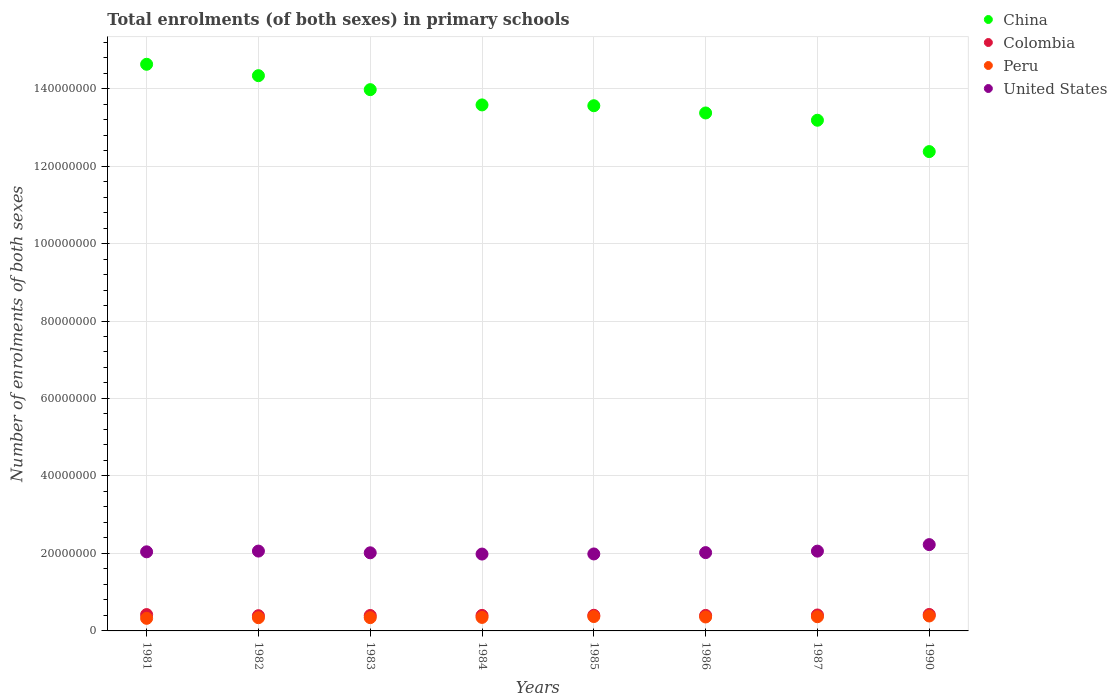Is the number of dotlines equal to the number of legend labels?
Your answer should be very brief. Yes. What is the number of enrolments in primary schools in Peru in 1981?
Your answer should be very brief. 3.25e+06. Across all years, what is the maximum number of enrolments in primary schools in Colombia?
Keep it short and to the point. 4.25e+06. Across all years, what is the minimum number of enrolments in primary schools in Colombia?
Give a very brief answer. 3.93e+06. In which year was the number of enrolments in primary schools in Colombia maximum?
Your response must be concise. 1990. What is the total number of enrolments in primary schools in Colombia in the graph?
Your answer should be compact. 3.25e+07. What is the difference between the number of enrolments in primary schools in United States in 1982 and that in 1983?
Provide a short and direct response. 4.43e+05. What is the difference between the number of enrolments in primary schools in China in 1990 and the number of enrolments in primary schools in United States in 1987?
Ensure brevity in your answer.  1.03e+08. What is the average number of enrolments in primary schools in United States per year?
Your response must be concise. 2.05e+07. In the year 1984, what is the difference between the number of enrolments in primary schools in Peru and number of enrolments in primary schools in Colombia?
Your answer should be very brief. -5.24e+05. In how many years, is the number of enrolments in primary schools in United States greater than 88000000?
Provide a succinct answer. 0. What is the ratio of the number of enrolments in primary schools in United States in 1983 to that in 1986?
Give a very brief answer. 1. What is the difference between the highest and the second highest number of enrolments in primary schools in United States?
Keep it short and to the point. 1.67e+06. What is the difference between the highest and the lowest number of enrolments in primary schools in China?
Your answer should be very brief. 2.25e+07. Is the sum of the number of enrolments in primary schools in China in 1983 and 1987 greater than the maximum number of enrolments in primary schools in Colombia across all years?
Give a very brief answer. Yes. Is it the case that in every year, the sum of the number of enrolments in primary schools in Colombia and number of enrolments in primary schools in Peru  is greater than the sum of number of enrolments in primary schools in China and number of enrolments in primary schools in United States?
Give a very brief answer. No. Is it the case that in every year, the sum of the number of enrolments in primary schools in China and number of enrolments in primary schools in Colombia  is greater than the number of enrolments in primary schools in United States?
Make the answer very short. Yes. Does the number of enrolments in primary schools in China monotonically increase over the years?
Keep it short and to the point. No. Is the number of enrolments in primary schools in China strictly less than the number of enrolments in primary schools in Colombia over the years?
Your answer should be compact. No. How many dotlines are there?
Your answer should be compact. 4. What is the difference between two consecutive major ticks on the Y-axis?
Offer a very short reply. 2.00e+07. Are the values on the major ticks of Y-axis written in scientific E-notation?
Your answer should be compact. No. Does the graph contain any zero values?
Keep it short and to the point. No. What is the title of the graph?
Keep it short and to the point. Total enrolments (of both sexes) in primary schools. Does "Poland" appear as one of the legend labels in the graph?
Ensure brevity in your answer.  No. What is the label or title of the Y-axis?
Offer a very short reply. Number of enrolments of both sexes. What is the Number of enrolments of both sexes of China in 1981?
Make the answer very short. 1.46e+08. What is the Number of enrolments of both sexes in Colombia in 1981?
Provide a short and direct response. 4.22e+06. What is the Number of enrolments of both sexes of Peru in 1981?
Keep it short and to the point. 3.25e+06. What is the Number of enrolments of both sexes of United States in 1981?
Your answer should be very brief. 2.04e+07. What is the Number of enrolments of both sexes of China in 1982?
Your response must be concise. 1.43e+08. What is the Number of enrolments of both sexes of Colombia in 1982?
Give a very brief answer. 3.93e+06. What is the Number of enrolments of both sexes in Peru in 1982?
Ensure brevity in your answer.  3.41e+06. What is the Number of enrolments of both sexes of United States in 1982?
Provide a short and direct response. 2.06e+07. What is the Number of enrolments of both sexes of China in 1983?
Offer a terse response. 1.40e+08. What is the Number of enrolments of both sexes of Colombia in 1983?
Provide a short and direct response. 3.98e+06. What is the Number of enrolments of both sexes in Peru in 1983?
Offer a very short reply. 3.43e+06. What is the Number of enrolments of both sexes in United States in 1983?
Your answer should be compact. 2.02e+07. What is the Number of enrolments of both sexes in China in 1984?
Offer a very short reply. 1.36e+08. What is the Number of enrolments of both sexes in Colombia in 1984?
Ensure brevity in your answer.  4.01e+06. What is the Number of enrolments of both sexes in Peru in 1984?
Offer a terse response. 3.48e+06. What is the Number of enrolments of both sexes of United States in 1984?
Provide a short and direct response. 1.98e+07. What is the Number of enrolments of both sexes of China in 1985?
Your answer should be very brief. 1.36e+08. What is the Number of enrolments of both sexes of Colombia in 1985?
Your answer should be compact. 4.04e+06. What is the Number of enrolments of both sexes in Peru in 1985?
Keep it short and to the point. 3.71e+06. What is the Number of enrolments of both sexes in United States in 1985?
Provide a succinct answer. 1.99e+07. What is the Number of enrolments of both sexes of China in 1986?
Your answer should be compact. 1.34e+08. What is the Number of enrolments of both sexes of Colombia in 1986?
Give a very brief answer. 4.00e+06. What is the Number of enrolments of both sexes in Peru in 1986?
Your answer should be compact. 3.60e+06. What is the Number of enrolments of both sexes in United States in 1986?
Your response must be concise. 2.02e+07. What is the Number of enrolments of both sexes in China in 1987?
Make the answer very short. 1.32e+08. What is the Number of enrolments of both sexes of Colombia in 1987?
Make the answer very short. 4.11e+06. What is the Number of enrolments of both sexes of Peru in 1987?
Your response must be concise. 3.66e+06. What is the Number of enrolments of both sexes of United States in 1987?
Your answer should be very brief. 2.06e+07. What is the Number of enrolments of both sexes of China in 1990?
Provide a short and direct response. 1.24e+08. What is the Number of enrolments of both sexes in Colombia in 1990?
Your answer should be very brief. 4.25e+06. What is the Number of enrolments of both sexes of Peru in 1990?
Make the answer very short. 3.86e+06. What is the Number of enrolments of both sexes of United States in 1990?
Make the answer very short. 2.23e+07. Across all years, what is the maximum Number of enrolments of both sexes in China?
Keep it short and to the point. 1.46e+08. Across all years, what is the maximum Number of enrolments of both sexes of Colombia?
Your response must be concise. 4.25e+06. Across all years, what is the maximum Number of enrolments of both sexes in Peru?
Offer a very short reply. 3.86e+06. Across all years, what is the maximum Number of enrolments of both sexes of United States?
Offer a very short reply. 2.23e+07. Across all years, what is the minimum Number of enrolments of both sexes in China?
Your answer should be very brief. 1.24e+08. Across all years, what is the minimum Number of enrolments of both sexes in Colombia?
Your answer should be compact. 3.93e+06. Across all years, what is the minimum Number of enrolments of both sexes in Peru?
Offer a very short reply. 3.25e+06. Across all years, what is the minimum Number of enrolments of both sexes of United States?
Offer a very short reply. 1.98e+07. What is the total Number of enrolments of both sexes in China in the graph?
Give a very brief answer. 1.09e+09. What is the total Number of enrolments of both sexes in Colombia in the graph?
Your response must be concise. 3.25e+07. What is the total Number of enrolments of both sexes of Peru in the graph?
Offer a very short reply. 2.84e+07. What is the total Number of enrolments of both sexes in United States in the graph?
Provide a succinct answer. 1.64e+08. What is the difference between the Number of enrolments of both sexes in China in 1981 and that in 1982?
Provide a succinct answer. 2.94e+06. What is the difference between the Number of enrolments of both sexes in Colombia in 1981 and that in 1982?
Your answer should be very brief. 2.87e+05. What is the difference between the Number of enrolments of both sexes in Peru in 1981 and that in 1982?
Provide a succinct answer. -1.61e+05. What is the difference between the Number of enrolments of both sexes of United States in 1981 and that in 1982?
Give a very brief answer. -1.89e+05. What is the difference between the Number of enrolments of both sexes in China in 1981 and that in 1983?
Keep it short and to the point. 6.55e+06. What is the difference between the Number of enrolments of both sexes in Colombia in 1981 and that in 1983?
Provide a succinct answer. 2.35e+05. What is the difference between the Number of enrolments of both sexes of Peru in 1981 and that in 1983?
Your response must be concise. -1.76e+05. What is the difference between the Number of enrolments of both sexes of United States in 1981 and that in 1983?
Your response must be concise. 2.54e+05. What is the difference between the Number of enrolments of both sexes in China in 1981 and that in 1984?
Give a very brief answer. 1.05e+07. What is the difference between the Number of enrolments of both sexes in Colombia in 1981 and that in 1984?
Your response must be concise. 2.08e+05. What is the difference between the Number of enrolments of both sexes of Peru in 1981 and that in 1984?
Your response must be concise. -2.33e+05. What is the difference between the Number of enrolments of both sexes of United States in 1981 and that in 1984?
Your response must be concise. 5.80e+05. What is the difference between the Number of enrolments of both sexes in China in 1981 and that in 1985?
Give a very brief answer. 1.07e+07. What is the difference between the Number of enrolments of both sexes of Colombia in 1981 and that in 1985?
Ensure brevity in your answer.  1.78e+05. What is the difference between the Number of enrolments of both sexes of Peru in 1981 and that in 1985?
Your response must be concise. -4.60e+05. What is the difference between the Number of enrolments of both sexes of United States in 1981 and that in 1985?
Give a very brief answer. 5.51e+05. What is the difference between the Number of enrolments of both sexes in China in 1981 and that in 1986?
Offer a terse response. 1.26e+07. What is the difference between the Number of enrolments of both sexes of Colombia in 1981 and that in 1986?
Your answer should be very brief. 2.15e+05. What is the difference between the Number of enrolments of both sexes in Peru in 1981 and that in 1986?
Your answer should be very brief. -3.49e+05. What is the difference between the Number of enrolments of both sexes in United States in 1981 and that in 1986?
Provide a short and direct response. 2.06e+05. What is the difference between the Number of enrolments of both sexes of China in 1981 and that in 1987?
Keep it short and to the point. 1.44e+07. What is the difference between the Number of enrolments of both sexes in Colombia in 1981 and that in 1987?
Your answer should be compact. 1.03e+05. What is the difference between the Number of enrolments of both sexes in Peru in 1981 and that in 1987?
Offer a very short reply. -4.11e+05. What is the difference between the Number of enrolments of both sexes of United States in 1981 and that in 1987?
Your answer should be compact. -1.75e+05. What is the difference between the Number of enrolments of both sexes in China in 1981 and that in 1990?
Your answer should be compact. 2.25e+07. What is the difference between the Number of enrolments of both sexes in Colombia in 1981 and that in 1990?
Give a very brief answer. -2.89e+04. What is the difference between the Number of enrolments of both sexes of Peru in 1981 and that in 1990?
Give a very brief answer. -6.03e+05. What is the difference between the Number of enrolments of both sexes in United States in 1981 and that in 1990?
Ensure brevity in your answer.  -1.86e+06. What is the difference between the Number of enrolments of both sexes in China in 1982 and that in 1983?
Keep it short and to the point. 3.61e+06. What is the difference between the Number of enrolments of both sexes of Colombia in 1982 and that in 1983?
Provide a short and direct response. -5.28e+04. What is the difference between the Number of enrolments of both sexes of Peru in 1982 and that in 1983?
Your response must be concise. -1.51e+04. What is the difference between the Number of enrolments of both sexes in United States in 1982 and that in 1983?
Make the answer very short. 4.43e+05. What is the difference between the Number of enrolments of both sexes of China in 1982 and that in 1984?
Offer a terse response. 7.55e+06. What is the difference between the Number of enrolments of both sexes of Colombia in 1982 and that in 1984?
Keep it short and to the point. -7.91e+04. What is the difference between the Number of enrolments of both sexes of Peru in 1982 and that in 1984?
Ensure brevity in your answer.  -7.22e+04. What is the difference between the Number of enrolments of both sexes of United States in 1982 and that in 1984?
Offer a terse response. 7.69e+05. What is the difference between the Number of enrolments of both sexes in China in 1982 and that in 1985?
Your response must be concise. 7.76e+06. What is the difference between the Number of enrolments of both sexes of Colombia in 1982 and that in 1985?
Offer a very short reply. -1.09e+05. What is the difference between the Number of enrolments of both sexes of Peru in 1982 and that in 1985?
Your response must be concise. -2.99e+05. What is the difference between the Number of enrolments of both sexes in United States in 1982 and that in 1985?
Ensure brevity in your answer.  7.40e+05. What is the difference between the Number of enrolments of both sexes of China in 1982 and that in 1986?
Your answer should be compact. 9.63e+06. What is the difference between the Number of enrolments of both sexes in Colombia in 1982 and that in 1986?
Offer a terse response. -7.22e+04. What is the difference between the Number of enrolments of both sexes of Peru in 1982 and that in 1986?
Provide a short and direct response. -1.88e+05. What is the difference between the Number of enrolments of both sexes in United States in 1982 and that in 1986?
Provide a short and direct response. 3.95e+05. What is the difference between the Number of enrolments of both sexes of China in 1982 and that in 1987?
Your answer should be very brief. 1.15e+07. What is the difference between the Number of enrolments of both sexes in Colombia in 1982 and that in 1987?
Your answer should be very brief. -1.85e+05. What is the difference between the Number of enrolments of both sexes of Peru in 1982 and that in 1987?
Offer a very short reply. -2.50e+05. What is the difference between the Number of enrolments of both sexes in United States in 1982 and that in 1987?
Offer a terse response. 1.40e+04. What is the difference between the Number of enrolments of both sexes of China in 1982 and that in 1990?
Ensure brevity in your answer.  1.96e+07. What is the difference between the Number of enrolments of both sexes in Colombia in 1982 and that in 1990?
Offer a very short reply. -3.16e+05. What is the difference between the Number of enrolments of both sexes in Peru in 1982 and that in 1990?
Offer a terse response. -4.43e+05. What is the difference between the Number of enrolments of both sexes in United States in 1982 and that in 1990?
Provide a short and direct response. -1.67e+06. What is the difference between the Number of enrolments of both sexes in China in 1983 and that in 1984?
Give a very brief answer. 3.94e+06. What is the difference between the Number of enrolments of both sexes of Colombia in 1983 and that in 1984?
Your response must be concise. -2.63e+04. What is the difference between the Number of enrolments of both sexes in Peru in 1983 and that in 1984?
Your response must be concise. -5.71e+04. What is the difference between the Number of enrolments of both sexes in United States in 1983 and that in 1984?
Offer a terse response. 3.26e+05. What is the difference between the Number of enrolments of both sexes of China in 1983 and that in 1985?
Offer a very short reply. 4.15e+06. What is the difference between the Number of enrolments of both sexes of Colombia in 1983 and that in 1985?
Ensure brevity in your answer.  -5.64e+04. What is the difference between the Number of enrolments of both sexes in Peru in 1983 and that in 1985?
Make the answer very short. -2.84e+05. What is the difference between the Number of enrolments of both sexes in United States in 1983 and that in 1985?
Give a very brief answer. 2.97e+05. What is the difference between the Number of enrolments of both sexes of China in 1983 and that in 1986?
Make the answer very short. 6.02e+06. What is the difference between the Number of enrolments of both sexes in Colombia in 1983 and that in 1986?
Make the answer very short. -1.94e+04. What is the difference between the Number of enrolments of both sexes of Peru in 1983 and that in 1986?
Keep it short and to the point. -1.72e+05. What is the difference between the Number of enrolments of both sexes in United States in 1983 and that in 1986?
Your answer should be very brief. -4.80e+04. What is the difference between the Number of enrolments of both sexes of China in 1983 and that in 1987?
Give a very brief answer. 7.90e+06. What is the difference between the Number of enrolments of both sexes in Colombia in 1983 and that in 1987?
Provide a succinct answer. -1.32e+05. What is the difference between the Number of enrolments of both sexes of Peru in 1983 and that in 1987?
Your answer should be very brief. -2.35e+05. What is the difference between the Number of enrolments of both sexes in United States in 1983 and that in 1987?
Give a very brief answer. -4.29e+05. What is the difference between the Number of enrolments of both sexes of China in 1983 and that in 1990?
Give a very brief answer. 1.60e+07. What is the difference between the Number of enrolments of both sexes in Colombia in 1983 and that in 1990?
Provide a short and direct response. -2.64e+05. What is the difference between the Number of enrolments of both sexes in Peru in 1983 and that in 1990?
Offer a very short reply. -4.27e+05. What is the difference between the Number of enrolments of both sexes of United States in 1983 and that in 1990?
Your response must be concise. -2.11e+06. What is the difference between the Number of enrolments of both sexes in China in 1984 and that in 1985?
Your answer should be very brief. 2.09e+05. What is the difference between the Number of enrolments of both sexes of Colombia in 1984 and that in 1985?
Give a very brief answer. -3.01e+04. What is the difference between the Number of enrolments of both sexes of Peru in 1984 and that in 1985?
Provide a short and direct response. -2.27e+05. What is the difference between the Number of enrolments of both sexes of United States in 1984 and that in 1985?
Give a very brief answer. -2.90e+04. What is the difference between the Number of enrolments of both sexes in China in 1984 and that in 1986?
Ensure brevity in your answer.  2.08e+06. What is the difference between the Number of enrolments of both sexes in Colombia in 1984 and that in 1986?
Your answer should be compact. 6880. What is the difference between the Number of enrolments of both sexes of Peru in 1984 and that in 1986?
Keep it short and to the point. -1.15e+05. What is the difference between the Number of enrolments of both sexes in United States in 1984 and that in 1986?
Offer a terse response. -3.74e+05. What is the difference between the Number of enrolments of both sexes in China in 1984 and that in 1987?
Ensure brevity in your answer.  3.96e+06. What is the difference between the Number of enrolments of both sexes in Colombia in 1984 and that in 1987?
Give a very brief answer. -1.06e+05. What is the difference between the Number of enrolments of both sexes of Peru in 1984 and that in 1987?
Your answer should be compact. -1.78e+05. What is the difference between the Number of enrolments of both sexes of United States in 1984 and that in 1987?
Provide a succinct answer. -7.55e+05. What is the difference between the Number of enrolments of both sexes in China in 1984 and that in 1990?
Your answer should be compact. 1.20e+07. What is the difference between the Number of enrolments of both sexes of Colombia in 1984 and that in 1990?
Give a very brief answer. -2.37e+05. What is the difference between the Number of enrolments of both sexes in Peru in 1984 and that in 1990?
Offer a very short reply. -3.70e+05. What is the difference between the Number of enrolments of both sexes in United States in 1984 and that in 1990?
Give a very brief answer. -2.44e+06. What is the difference between the Number of enrolments of both sexes of China in 1985 and that in 1986?
Provide a succinct answer. 1.87e+06. What is the difference between the Number of enrolments of both sexes of Colombia in 1985 and that in 1986?
Your response must be concise. 3.70e+04. What is the difference between the Number of enrolments of both sexes of Peru in 1985 and that in 1986?
Keep it short and to the point. 1.11e+05. What is the difference between the Number of enrolments of both sexes in United States in 1985 and that in 1986?
Provide a succinct answer. -3.45e+05. What is the difference between the Number of enrolments of both sexes in China in 1985 and that in 1987?
Provide a short and direct response. 3.75e+06. What is the difference between the Number of enrolments of both sexes of Colombia in 1985 and that in 1987?
Provide a short and direct response. -7.54e+04. What is the difference between the Number of enrolments of both sexes of Peru in 1985 and that in 1987?
Give a very brief answer. 4.85e+04. What is the difference between the Number of enrolments of both sexes in United States in 1985 and that in 1987?
Give a very brief answer. -7.26e+05. What is the difference between the Number of enrolments of both sexes in China in 1985 and that in 1990?
Provide a succinct answer. 1.18e+07. What is the difference between the Number of enrolments of both sexes in Colombia in 1985 and that in 1990?
Keep it short and to the point. -2.07e+05. What is the difference between the Number of enrolments of both sexes of Peru in 1985 and that in 1990?
Offer a very short reply. -1.44e+05. What is the difference between the Number of enrolments of both sexes in United States in 1985 and that in 1990?
Make the answer very short. -2.41e+06. What is the difference between the Number of enrolments of both sexes in China in 1986 and that in 1987?
Offer a very short reply. 1.88e+06. What is the difference between the Number of enrolments of both sexes in Colombia in 1986 and that in 1987?
Ensure brevity in your answer.  -1.12e+05. What is the difference between the Number of enrolments of both sexes in Peru in 1986 and that in 1987?
Offer a very short reply. -6.27e+04. What is the difference between the Number of enrolments of both sexes of United States in 1986 and that in 1987?
Ensure brevity in your answer.  -3.81e+05. What is the difference between the Number of enrolments of both sexes of China in 1986 and that in 1990?
Your answer should be very brief. 9.97e+06. What is the difference between the Number of enrolments of both sexes in Colombia in 1986 and that in 1990?
Your answer should be very brief. -2.44e+05. What is the difference between the Number of enrolments of both sexes in Peru in 1986 and that in 1990?
Provide a short and direct response. -2.55e+05. What is the difference between the Number of enrolments of both sexes of United States in 1986 and that in 1990?
Your answer should be compact. -2.06e+06. What is the difference between the Number of enrolments of both sexes of China in 1987 and that in 1990?
Give a very brief answer. 8.09e+06. What is the difference between the Number of enrolments of both sexes of Colombia in 1987 and that in 1990?
Keep it short and to the point. -1.32e+05. What is the difference between the Number of enrolments of both sexes in Peru in 1987 and that in 1990?
Give a very brief answer. -1.92e+05. What is the difference between the Number of enrolments of both sexes of United States in 1987 and that in 1990?
Provide a short and direct response. -1.68e+06. What is the difference between the Number of enrolments of both sexes of China in 1981 and the Number of enrolments of both sexes of Colombia in 1982?
Offer a very short reply. 1.42e+08. What is the difference between the Number of enrolments of both sexes of China in 1981 and the Number of enrolments of both sexes of Peru in 1982?
Offer a very short reply. 1.43e+08. What is the difference between the Number of enrolments of both sexes in China in 1981 and the Number of enrolments of both sexes in United States in 1982?
Ensure brevity in your answer.  1.26e+08. What is the difference between the Number of enrolments of both sexes in Colombia in 1981 and the Number of enrolments of both sexes in Peru in 1982?
Make the answer very short. 8.05e+05. What is the difference between the Number of enrolments of both sexes of Colombia in 1981 and the Number of enrolments of both sexes of United States in 1982?
Ensure brevity in your answer.  -1.64e+07. What is the difference between the Number of enrolments of both sexes of Peru in 1981 and the Number of enrolments of both sexes of United States in 1982?
Ensure brevity in your answer.  -1.74e+07. What is the difference between the Number of enrolments of both sexes in China in 1981 and the Number of enrolments of both sexes in Colombia in 1983?
Give a very brief answer. 1.42e+08. What is the difference between the Number of enrolments of both sexes of China in 1981 and the Number of enrolments of both sexes of Peru in 1983?
Make the answer very short. 1.43e+08. What is the difference between the Number of enrolments of both sexes of China in 1981 and the Number of enrolments of both sexes of United States in 1983?
Offer a very short reply. 1.26e+08. What is the difference between the Number of enrolments of both sexes in Colombia in 1981 and the Number of enrolments of both sexes in Peru in 1983?
Your answer should be very brief. 7.90e+05. What is the difference between the Number of enrolments of both sexes of Colombia in 1981 and the Number of enrolments of both sexes of United States in 1983?
Make the answer very short. -1.59e+07. What is the difference between the Number of enrolments of both sexes in Peru in 1981 and the Number of enrolments of both sexes in United States in 1983?
Your response must be concise. -1.69e+07. What is the difference between the Number of enrolments of both sexes in China in 1981 and the Number of enrolments of both sexes in Colombia in 1984?
Keep it short and to the point. 1.42e+08. What is the difference between the Number of enrolments of both sexes in China in 1981 and the Number of enrolments of both sexes in Peru in 1984?
Provide a short and direct response. 1.43e+08. What is the difference between the Number of enrolments of both sexes of China in 1981 and the Number of enrolments of both sexes of United States in 1984?
Make the answer very short. 1.26e+08. What is the difference between the Number of enrolments of both sexes of Colombia in 1981 and the Number of enrolments of both sexes of Peru in 1984?
Ensure brevity in your answer.  7.33e+05. What is the difference between the Number of enrolments of both sexes in Colombia in 1981 and the Number of enrolments of both sexes in United States in 1984?
Give a very brief answer. -1.56e+07. What is the difference between the Number of enrolments of both sexes in Peru in 1981 and the Number of enrolments of both sexes in United States in 1984?
Offer a terse response. -1.66e+07. What is the difference between the Number of enrolments of both sexes in China in 1981 and the Number of enrolments of both sexes in Colombia in 1985?
Keep it short and to the point. 1.42e+08. What is the difference between the Number of enrolments of both sexes in China in 1981 and the Number of enrolments of both sexes in Peru in 1985?
Ensure brevity in your answer.  1.43e+08. What is the difference between the Number of enrolments of both sexes in China in 1981 and the Number of enrolments of both sexes in United States in 1985?
Your answer should be compact. 1.26e+08. What is the difference between the Number of enrolments of both sexes of Colombia in 1981 and the Number of enrolments of both sexes of Peru in 1985?
Give a very brief answer. 5.06e+05. What is the difference between the Number of enrolments of both sexes in Colombia in 1981 and the Number of enrolments of both sexes in United States in 1985?
Make the answer very short. -1.57e+07. What is the difference between the Number of enrolments of both sexes of Peru in 1981 and the Number of enrolments of both sexes of United States in 1985?
Provide a succinct answer. -1.66e+07. What is the difference between the Number of enrolments of both sexes of China in 1981 and the Number of enrolments of both sexes of Colombia in 1986?
Keep it short and to the point. 1.42e+08. What is the difference between the Number of enrolments of both sexes in China in 1981 and the Number of enrolments of both sexes in Peru in 1986?
Offer a terse response. 1.43e+08. What is the difference between the Number of enrolments of both sexes of China in 1981 and the Number of enrolments of both sexes of United States in 1986?
Provide a succinct answer. 1.26e+08. What is the difference between the Number of enrolments of both sexes in Colombia in 1981 and the Number of enrolments of both sexes in Peru in 1986?
Your answer should be very brief. 6.17e+05. What is the difference between the Number of enrolments of both sexes in Colombia in 1981 and the Number of enrolments of both sexes in United States in 1986?
Offer a terse response. -1.60e+07. What is the difference between the Number of enrolments of both sexes of Peru in 1981 and the Number of enrolments of both sexes of United States in 1986?
Give a very brief answer. -1.70e+07. What is the difference between the Number of enrolments of both sexes of China in 1981 and the Number of enrolments of both sexes of Colombia in 1987?
Your answer should be compact. 1.42e+08. What is the difference between the Number of enrolments of both sexes of China in 1981 and the Number of enrolments of both sexes of Peru in 1987?
Provide a short and direct response. 1.43e+08. What is the difference between the Number of enrolments of both sexes of China in 1981 and the Number of enrolments of both sexes of United States in 1987?
Ensure brevity in your answer.  1.26e+08. What is the difference between the Number of enrolments of both sexes of Colombia in 1981 and the Number of enrolments of both sexes of Peru in 1987?
Ensure brevity in your answer.  5.55e+05. What is the difference between the Number of enrolments of both sexes of Colombia in 1981 and the Number of enrolments of both sexes of United States in 1987?
Your answer should be compact. -1.64e+07. What is the difference between the Number of enrolments of both sexes of Peru in 1981 and the Number of enrolments of both sexes of United States in 1987?
Make the answer very short. -1.73e+07. What is the difference between the Number of enrolments of both sexes of China in 1981 and the Number of enrolments of both sexes of Colombia in 1990?
Ensure brevity in your answer.  1.42e+08. What is the difference between the Number of enrolments of both sexes of China in 1981 and the Number of enrolments of both sexes of Peru in 1990?
Your response must be concise. 1.42e+08. What is the difference between the Number of enrolments of both sexes of China in 1981 and the Number of enrolments of both sexes of United States in 1990?
Keep it short and to the point. 1.24e+08. What is the difference between the Number of enrolments of both sexes of Colombia in 1981 and the Number of enrolments of both sexes of Peru in 1990?
Provide a succinct answer. 3.63e+05. What is the difference between the Number of enrolments of both sexes of Colombia in 1981 and the Number of enrolments of both sexes of United States in 1990?
Provide a short and direct response. -1.81e+07. What is the difference between the Number of enrolments of both sexes in Peru in 1981 and the Number of enrolments of both sexes in United States in 1990?
Provide a short and direct response. -1.90e+07. What is the difference between the Number of enrolments of both sexes in China in 1982 and the Number of enrolments of both sexes in Colombia in 1983?
Your response must be concise. 1.39e+08. What is the difference between the Number of enrolments of both sexes of China in 1982 and the Number of enrolments of both sexes of Peru in 1983?
Your response must be concise. 1.40e+08. What is the difference between the Number of enrolments of both sexes of China in 1982 and the Number of enrolments of both sexes of United States in 1983?
Offer a terse response. 1.23e+08. What is the difference between the Number of enrolments of both sexes of Colombia in 1982 and the Number of enrolments of both sexes of Peru in 1983?
Ensure brevity in your answer.  5.02e+05. What is the difference between the Number of enrolments of both sexes in Colombia in 1982 and the Number of enrolments of both sexes in United States in 1983?
Keep it short and to the point. -1.62e+07. What is the difference between the Number of enrolments of both sexes of Peru in 1982 and the Number of enrolments of both sexes of United States in 1983?
Make the answer very short. -1.68e+07. What is the difference between the Number of enrolments of both sexes of China in 1982 and the Number of enrolments of both sexes of Colombia in 1984?
Offer a terse response. 1.39e+08. What is the difference between the Number of enrolments of both sexes of China in 1982 and the Number of enrolments of both sexes of Peru in 1984?
Offer a very short reply. 1.40e+08. What is the difference between the Number of enrolments of both sexes in China in 1982 and the Number of enrolments of both sexes in United States in 1984?
Offer a terse response. 1.23e+08. What is the difference between the Number of enrolments of both sexes of Colombia in 1982 and the Number of enrolments of both sexes of Peru in 1984?
Keep it short and to the point. 4.45e+05. What is the difference between the Number of enrolments of both sexes in Colombia in 1982 and the Number of enrolments of both sexes in United States in 1984?
Offer a terse response. -1.59e+07. What is the difference between the Number of enrolments of both sexes of Peru in 1982 and the Number of enrolments of both sexes of United States in 1984?
Ensure brevity in your answer.  -1.64e+07. What is the difference between the Number of enrolments of both sexes in China in 1982 and the Number of enrolments of both sexes in Colombia in 1985?
Ensure brevity in your answer.  1.39e+08. What is the difference between the Number of enrolments of both sexes in China in 1982 and the Number of enrolments of both sexes in Peru in 1985?
Offer a very short reply. 1.40e+08. What is the difference between the Number of enrolments of both sexes of China in 1982 and the Number of enrolments of both sexes of United States in 1985?
Ensure brevity in your answer.  1.23e+08. What is the difference between the Number of enrolments of both sexes in Colombia in 1982 and the Number of enrolments of both sexes in Peru in 1985?
Your answer should be very brief. 2.19e+05. What is the difference between the Number of enrolments of both sexes of Colombia in 1982 and the Number of enrolments of both sexes of United States in 1985?
Offer a very short reply. -1.59e+07. What is the difference between the Number of enrolments of both sexes of Peru in 1982 and the Number of enrolments of both sexes of United States in 1985?
Your answer should be very brief. -1.65e+07. What is the difference between the Number of enrolments of both sexes of China in 1982 and the Number of enrolments of both sexes of Colombia in 1986?
Keep it short and to the point. 1.39e+08. What is the difference between the Number of enrolments of both sexes in China in 1982 and the Number of enrolments of both sexes in Peru in 1986?
Make the answer very short. 1.40e+08. What is the difference between the Number of enrolments of both sexes of China in 1982 and the Number of enrolments of both sexes of United States in 1986?
Make the answer very short. 1.23e+08. What is the difference between the Number of enrolments of both sexes in Colombia in 1982 and the Number of enrolments of both sexes in Peru in 1986?
Your response must be concise. 3.30e+05. What is the difference between the Number of enrolments of both sexes of Colombia in 1982 and the Number of enrolments of both sexes of United States in 1986?
Ensure brevity in your answer.  -1.63e+07. What is the difference between the Number of enrolments of both sexes in Peru in 1982 and the Number of enrolments of both sexes in United States in 1986?
Your answer should be very brief. -1.68e+07. What is the difference between the Number of enrolments of both sexes in China in 1982 and the Number of enrolments of both sexes in Colombia in 1987?
Provide a short and direct response. 1.39e+08. What is the difference between the Number of enrolments of both sexes of China in 1982 and the Number of enrolments of both sexes of Peru in 1987?
Offer a terse response. 1.40e+08. What is the difference between the Number of enrolments of both sexes of China in 1982 and the Number of enrolments of both sexes of United States in 1987?
Offer a terse response. 1.23e+08. What is the difference between the Number of enrolments of both sexes of Colombia in 1982 and the Number of enrolments of both sexes of Peru in 1987?
Your answer should be compact. 2.67e+05. What is the difference between the Number of enrolments of both sexes of Colombia in 1982 and the Number of enrolments of both sexes of United States in 1987?
Offer a very short reply. -1.67e+07. What is the difference between the Number of enrolments of both sexes of Peru in 1982 and the Number of enrolments of both sexes of United States in 1987?
Keep it short and to the point. -1.72e+07. What is the difference between the Number of enrolments of both sexes of China in 1982 and the Number of enrolments of both sexes of Colombia in 1990?
Your response must be concise. 1.39e+08. What is the difference between the Number of enrolments of both sexes of China in 1982 and the Number of enrolments of both sexes of Peru in 1990?
Your response must be concise. 1.39e+08. What is the difference between the Number of enrolments of both sexes of China in 1982 and the Number of enrolments of both sexes of United States in 1990?
Your answer should be very brief. 1.21e+08. What is the difference between the Number of enrolments of both sexes in Colombia in 1982 and the Number of enrolments of both sexes in Peru in 1990?
Offer a terse response. 7.50e+04. What is the difference between the Number of enrolments of both sexes of Colombia in 1982 and the Number of enrolments of both sexes of United States in 1990?
Provide a short and direct response. -1.83e+07. What is the difference between the Number of enrolments of both sexes of Peru in 1982 and the Number of enrolments of both sexes of United States in 1990?
Make the answer very short. -1.89e+07. What is the difference between the Number of enrolments of both sexes in China in 1983 and the Number of enrolments of both sexes in Colombia in 1984?
Ensure brevity in your answer.  1.36e+08. What is the difference between the Number of enrolments of both sexes of China in 1983 and the Number of enrolments of both sexes of Peru in 1984?
Offer a very short reply. 1.36e+08. What is the difference between the Number of enrolments of both sexes in China in 1983 and the Number of enrolments of both sexes in United States in 1984?
Your answer should be compact. 1.20e+08. What is the difference between the Number of enrolments of both sexes in Colombia in 1983 and the Number of enrolments of both sexes in Peru in 1984?
Your answer should be compact. 4.98e+05. What is the difference between the Number of enrolments of both sexes of Colombia in 1983 and the Number of enrolments of both sexes of United States in 1984?
Ensure brevity in your answer.  -1.59e+07. What is the difference between the Number of enrolments of both sexes in Peru in 1983 and the Number of enrolments of both sexes in United States in 1984?
Give a very brief answer. -1.64e+07. What is the difference between the Number of enrolments of both sexes of China in 1983 and the Number of enrolments of both sexes of Colombia in 1985?
Make the answer very short. 1.36e+08. What is the difference between the Number of enrolments of both sexes of China in 1983 and the Number of enrolments of both sexes of Peru in 1985?
Ensure brevity in your answer.  1.36e+08. What is the difference between the Number of enrolments of both sexes in China in 1983 and the Number of enrolments of both sexes in United States in 1985?
Give a very brief answer. 1.20e+08. What is the difference between the Number of enrolments of both sexes in Colombia in 1983 and the Number of enrolments of both sexes in Peru in 1985?
Your answer should be compact. 2.72e+05. What is the difference between the Number of enrolments of both sexes in Colombia in 1983 and the Number of enrolments of both sexes in United States in 1985?
Keep it short and to the point. -1.59e+07. What is the difference between the Number of enrolments of both sexes of Peru in 1983 and the Number of enrolments of both sexes of United States in 1985?
Provide a short and direct response. -1.64e+07. What is the difference between the Number of enrolments of both sexes of China in 1983 and the Number of enrolments of both sexes of Colombia in 1986?
Provide a short and direct response. 1.36e+08. What is the difference between the Number of enrolments of both sexes in China in 1983 and the Number of enrolments of both sexes in Peru in 1986?
Your response must be concise. 1.36e+08. What is the difference between the Number of enrolments of both sexes of China in 1983 and the Number of enrolments of both sexes of United States in 1986?
Provide a short and direct response. 1.20e+08. What is the difference between the Number of enrolments of both sexes in Colombia in 1983 and the Number of enrolments of both sexes in Peru in 1986?
Provide a succinct answer. 3.83e+05. What is the difference between the Number of enrolments of both sexes in Colombia in 1983 and the Number of enrolments of both sexes in United States in 1986?
Offer a very short reply. -1.62e+07. What is the difference between the Number of enrolments of both sexes of Peru in 1983 and the Number of enrolments of both sexes of United States in 1986?
Provide a succinct answer. -1.68e+07. What is the difference between the Number of enrolments of both sexes of China in 1983 and the Number of enrolments of both sexes of Colombia in 1987?
Give a very brief answer. 1.36e+08. What is the difference between the Number of enrolments of both sexes in China in 1983 and the Number of enrolments of both sexes in Peru in 1987?
Give a very brief answer. 1.36e+08. What is the difference between the Number of enrolments of both sexes in China in 1983 and the Number of enrolments of both sexes in United States in 1987?
Your response must be concise. 1.19e+08. What is the difference between the Number of enrolments of both sexes of Colombia in 1983 and the Number of enrolments of both sexes of Peru in 1987?
Provide a short and direct response. 3.20e+05. What is the difference between the Number of enrolments of both sexes of Colombia in 1983 and the Number of enrolments of both sexes of United States in 1987?
Keep it short and to the point. -1.66e+07. What is the difference between the Number of enrolments of both sexes in Peru in 1983 and the Number of enrolments of both sexes in United States in 1987?
Provide a succinct answer. -1.72e+07. What is the difference between the Number of enrolments of both sexes of China in 1983 and the Number of enrolments of both sexes of Colombia in 1990?
Offer a very short reply. 1.35e+08. What is the difference between the Number of enrolments of both sexes in China in 1983 and the Number of enrolments of both sexes in Peru in 1990?
Make the answer very short. 1.36e+08. What is the difference between the Number of enrolments of both sexes in China in 1983 and the Number of enrolments of both sexes in United States in 1990?
Your answer should be compact. 1.17e+08. What is the difference between the Number of enrolments of both sexes of Colombia in 1983 and the Number of enrolments of both sexes of Peru in 1990?
Provide a succinct answer. 1.28e+05. What is the difference between the Number of enrolments of both sexes in Colombia in 1983 and the Number of enrolments of both sexes in United States in 1990?
Ensure brevity in your answer.  -1.83e+07. What is the difference between the Number of enrolments of both sexes in Peru in 1983 and the Number of enrolments of both sexes in United States in 1990?
Provide a succinct answer. -1.89e+07. What is the difference between the Number of enrolments of both sexes of China in 1984 and the Number of enrolments of both sexes of Colombia in 1985?
Your answer should be very brief. 1.32e+08. What is the difference between the Number of enrolments of both sexes in China in 1984 and the Number of enrolments of both sexes in Peru in 1985?
Provide a short and direct response. 1.32e+08. What is the difference between the Number of enrolments of both sexes of China in 1984 and the Number of enrolments of both sexes of United States in 1985?
Offer a very short reply. 1.16e+08. What is the difference between the Number of enrolments of both sexes in Colombia in 1984 and the Number of enrolments of both sexes in Peru in 1985?
Your answer should be very brief. 2.98e+05. What is the difference between the Number of enrolments of both sexes of Colombia in 1984 and the Number of enrolments of both sexes of United States in 1985?
Offer a very short reply. -1.59e+07. What is the difference between the Number of enrolments of both sexes of Peru in 1984 and the Number of enrolments of both sexes of United States in 1985?
Offer a terse response. -1.64e+07. What is the difference between the Number of enrolments of both sexes of China in 1984 and the Number of enrolments of both sexes of Colombia in 1986?
Your response must be concise. 1.32e+08. What is the difference between the Number of enrolments of both sexes in China in 1984 and the Number of enrolments of both sexes in Peru in 1986?
Offer a terse response. 1.32e+08. What is the difference between the Number of enrolments of both sexes of China in 1984 and the Number of enrolments of both sexes of United States in 1986?
Make the answer very short. 1.16e+08. What is the difference between the Number of enrolments of both sexes of Colombia in 1984 and the Number of enrolments of both sexes of Peru in 1986?
Your answer should be compact. 4.09e+05. What is the difference between the Number of enrolments of both sexes in Colombia in 1984 and the Number of enrolments of both sexes in United States in 1986?
Provide a short and direct response. -1.62e+07. What is the difference between the Number of enrolments of both sexes in Peru in 1984 and the Number of enrolments of both sexes in United States in 1986?
Your answer should be very brief. -1.67e+07. What is the difference between the Number of enrolments of both sexes of China in 1984 and the Number of enrolments of both sexes of Colombia in 1987?
Offer a terse response. 1.32e+08. What is the difference between the Number of enrolments of both sexes in China in 1984 and the Number of enrolments of both sexes in Peru in 1987?
Offer a very short reply. 1.32e+08. What is the difference between the Number of enrolments of both sexes in China in 1984 and the Number of enrolments of both sexes in United States in 1987?
Give a very brief answer. 1.15e+08. What is the difference between the Number of enrolments of both sexes in Colombia in 1984 and the Number of enrolments of both sexes in Peru in 1987?
Your answer should be very brief. 3.46e+05. What is the difference between the Number of enrolments of both sexes in Colombia in 1984 and the Number of enrolments of both sexes in United States in 1987?
Give a very brief answer. -1.66e+07. What is the difference between the Number of enrolments of both sexes of Peru in 1984 and the Number of enrolments of both sexes of United States in 1987?
Your answer should be very brief. -1.71e+07. What is the difference between the Number of enrolments of both sexes of China in 1984 and the Number of enrolments of both sexes of Colombia in 1990?
Make the answer very short. 1.32e+08. What is the difference between the Number of enrolments of both sexes in China in 1984 and the Number of enrolments of both sexes in Peru in 1990?
Keep it short and to the point. 1.32e+08. What is the difference between the Number of enrolments of both sexes of China in 1984 and the Number of enrolments of both sexes of United States in 1990?
Ensure brevity in your answer.  1.14e+08. What is the difference between the Number of enrolments of both sexes in Colombia in 1984 and the Number of enrolments of both sexes in Peru in 1990?
Your response must be concise. 1.54e+05. What is the difference between the Number of enrolments of both sexes of Colombia in 1984 and the Number of enrolments of both sexes of United States in 1990?
Your answer should be compact. -1.83e+07. What is the difference between the Number of enrolments of both sexes of Peru in 1984 and the Number of enrolments of both sexes of United States in 1990?
Offer a very short reply. -1.88e+07. What is the difference between the Number of enrolments of both sexes of China in 1985 and the Number of enrolments of both sexes of Colombia in 1986?
Make the answer very short. 1.32e+08. What is the difference between the Number of enrolments of both sexes in China in 1985 and the Number of enrolments of both sexes in Peru in 1986?
Provide a succinct answer. 1.32e+08. What is the difference between the Number of enrolments of both sexes of China in 1985 and the Number of enrolments of both sexes of United States in 1986?
Your answer should be compact. 1.15e+08. What is the difference between the Number of enrolments of both sexes in Colombia in 1985 and the Number of enrolments of both sexes in Peru in 1986?
Provide a short and direct response. 4.39e+05. What is the difference between the Number of enrolments of both sexes of Colombia in 1985 and the Number of enrolments of both sexes of United States in 1986?
Your answer should be very brief. -1.62e+07. What is the difference between the Number of enrolments of both sexes in Peru in 1985 and the Number of enrolments of both sexes in United States in 1986?
Offer a terse response. -1.65e+07. What is the difference between the Number of enrolments of both sexes of China in 1985 and the Number of enrolments of both sexes of Colombia in 1987?
Provide a succinct answer. 1.31e+08. What is the difference between the Number of enrolments of both sexes of China in 1985 and the Number of enrolments of both sexes of Peru in 1987?
Your response must be concise. 1.32e+08. What is the difference between the Number of enrolments of both sexes in China in 1985 and the Number of enrolments of both sexes in United States in 1987?
Make the answer very short. 1.15e+08. What is the difference between the Number of enrolments of both sexes of Colombia in 1985 and the Number of enrolments of both sexes of Peru in 1987?
Provide a short and direct response. 3.76e+05. What is the difference between the Number of enrolments of both sexes of Colombia in 1985 and the Number of enrolments of both sexes of United States in 1987?
Provide a short and direct response. -1.66e+07. What is the difference between the Number of enrolments of both sexes of Peru in 1985 and the Number of enrolments of both sexes of United States in 1987?
Provide a succinct answer. -1.69e+07. What is the difference between the Number of enrolments of both sexes in China in 1985 and the Number of enrolments of both sexes in Colombia in 1990?
Provide a short and direct response. 1.31e+08. What is the difference between the Number of enrolments of both sexes in China in 1985 and the Number of enrolments of both sexes in Peru in 1990?
Offer a very short reply. 1.32e+08. What is the difference between the Number of enrolments of both sexes of China in 1985 and the Number of enrolments of both sexes of United States in 1990?
Ensure brevity in your answer.  1.13e+08. What is the difference between the Number of enrolments of both sexes of Colombia in 1985 and the Number of enrolments of both sexes of Peru in 1990?
Keep it short and to the point. 1.84e+05. What is the difference between the Number of enrolments of both sexes in Colombia in 1985 and the Number of enrolments of both sexes in United States in 1990?
Provide a succinct answer. -1.82e+07. What is the difference between the Number of enrolments of both sexes in Peru in 1985 and the Number of enrolments of both sexes in United States in 1990?
Your answer should be very brief. -1.86e+07. What is the difference between the Number of enrolments of both sexes in China in 1986 and the Number of enrolments of both sexes in Colombia in 1987?
Your answer should be compact. 1.30e+08. What is the difference between the Number of enrolments of both sexes in China in 1986 and the Number of enrolments of both sexes in Peru in 1987?
Make the answer very short. 1.30e+08. What is the difference between the Number of enrolments of both sexes in China in 1986 and the Number of enrolments of both sexes in United States in 1987?
Make the answer very short. 1.13e+08. What is the difference between the Number of enrolments of both sexes of Colombia in 1986 and the Number of enrolments of both sexes of Peru in 1987?
Your response must be concise. 3.39e+05. What is the difference between the Number of enrolments of both sexes of Colombia in 1986 and the Number of enrolments of both sexes of United States in 1987?
Your answer should be very brief. -1.66e+07. What is the difference between the Number of enrolments of both sexes of Peru in 1986 and the Number of enrolments of both sexes of United States in 1987?
Ensure brevity in your answer.  -1.70e+07. What is the difference between the Number of enrolments of both sexes of China in 1986 and the Number of enrolments of both sexes of Colombia in 1990?
Keep it short and to the point. 1.29e+08. What is the difference between the Number of enrolments of both sexes in China in 1986 and the Number of enrolments of both sexes in Peru in 1990?
Keep it short and to the point. 1.30e+08. What is the difference between the Number of enrolments of both sexes in China in 1986 and the Number of enrolments of both sexes in United States in 1990?
Your response must be concise. 1.11e+08. What is the difference between the Number of enrolments of both sexes of Colombia in 1986 and the Number of enrolments of both sexes of Peru in 1990?
Provide a short and direct response. 1.47e+05. What is the difference between the Number of enrolments of both sexes in Colombia in 1986 and the Number of enrolments of both sexes in United States in 1990?
Your answer should be compact. -1.83e+07. What is the difference between the Number of enrolments of both sexes in Peru in 1986 and the Number of enrolments of both sexes in United States in 1990?
Provide a succinct answer. -1.87e+07. What is the difference between the Number of enrolments of both sexes of China in 1987 and the Number of enrolments of both sexes of Colombia in 1990?
Your answer should be very brief. 1.28e+08. What is the difference between the Number of enrolments of both sexes in China in 1987 and the Number of enrolments of both sexes in Peru in 1990?
Keep it short and to the point. 1.28e+08. What is the difference between the Number of enrolments of both sexes in China in 1987 and the Number of enrolments of both sexes in United States in 1990?
Provide a succinct answer. 1.10e+08. What is the difference between the Number of enrolments of both sexes of Colombia in 1987 and the Number of enrolments of both sexes of Peru in 1990?
Provide a succinct answer. 2.60e+05. What is the difference between the Number of enrolments of both sexes in Colombia in 1987 and the Number of enrolments of both sexes in United States in 1990?
Offer a very short reply. -1.82e+07. What is the difference between the Number of enrolments of both sexes in Peru in 1987 and the Number of enrolments of both sexes in United States in 1990?
Your answer should be very brief. -1.86e+07. What is the average Number of enrolments of both sexes in China per year?
Ensure brevity in your answer.  1.36e+08. What is the average Number of enrolments of both sexes of Colombia per year?
Your answer should be very brief. 4.07e+06. What is the average Number of enrolments of both sexes of Peru per year?
Keep it short and to the point. 3.55e+06. What is the average Number of enrolments of both sexes of United States per year?
Your answer should be very brief. 2.05e+07. In the year 1981, what is the difference between the Number of enrolments of both sexes of China and Number of enrolments of both sexes of Colombia?
Give a very brief answer. 1.42e+08. In the year 1981, what is the difference between the Number of enrolments of both sexes of China and Number of enrolments of both sexes of Peru?
Your answer should be very brief. 1.43e+08. In the year 1981, what is the difference between the Number of enrolments of both sexes in China and Number of enrolments of both sexes in United States?
Give a very brief answer. 1.26e+08. In the year 1981, what is the difference between the Number of enrolments of both sexes of Colombia and Number of enrolments of both sexes of Peru?
Provide a succinct answer. 9.66e+05. In the year 1981, what is the difference between the Number of enrolments of both sexes of Colombia and Number of enrolments of both sexes of United States?
Provide a succinct answer. -1.62e+07. In the year 1981, what is the difference between the Number of enrolments of both sexes of Peru and Number of enrolments of both sexes of United States?
Make the answer very short. -1.72e+07. In the year 1982, what is the difference between the Number of enrolments of both sexes in China and Number of enrolments of both sexes in Colombia?
Your answer should be compact. 1.39e+08. In the year 1982, what is the difference between the Number of enrolments of both sexes in China and Number of enrolments of both sexes in Peru?
Make the answer very short. 1.40e+08. In the year 1982, what is the difference between the Number of enrolments of both sexes of China and Number of enrolments of both sexes of United States?
Offer a very short reply. 1.23e+08. In the year 1982, what is the difference between the Number of enrolments of both sexes of Colombia and Number of enrolments of both sexes of Peru?
Offer a very short reply. 5.18e+05. In the year 1982, what is the difference between the Number of enrolments of both sexes of Colombia and Number of enrolments of both sexes of United States?
Provide a short and direct response. -1.67e+07. In the year 1982, what is the difference between the Number of enrolments of both sexes of Peru and Number of enrolments of both sexes of United States?
Your response must be concise. -1.72e+07. In the year 1983, what is the difference between the Number of enrolments of both sexes of China and Number of enrolments of both sexes of Colombia?
Give a very brief answer. 1.36e+08. In the year 1983, what is the difference between the Number of enrolments of both sexes of China and Number of enrolments of both sexes of Peru?
Your answer should be compact. 1.36e+08. In the year 1983, what is the difference between the Number of enrolments of both sexes of China and Number of enrolments of both sexes of United States?
Your answer should be compact. 1.20e+08. In the year 1983, what is the difference between the Number of enrolments of both sexes in Colombia and Number of enrolments of both sexes in Peru?
Provide a short and direct response. 5.55e+05. In the year 1983, what is the difference between the Number of enrolments of both sexes of Colombia and Number of enrolments of both sexes of United States?
Make the answer very short. -1.62e+07. In the year 1983, what is the difference between the Number of enrolments of both sexes in Peru and Number of enrolments of both sexes in United States?
Your response must be concise. -1.67e+07. In the year 1984, what is the difference between the Number of enrolments of both sexes of China and Number of enrolments of both sexes of Colombia?
Your response must be concise. 1.32e+08. In the year 1984, what is the difference between the Number of enrolments of both sexes in China and Number of enrolments of both sexes in Peru?
Keep it short and to the point. 1.32e+08. In the year 1984, what is the difference between the Number of enrolments of both sexes of China and Number of enrolments of both sexes of United States?
Provide a short and direct response. 1.16e+08. In the year 1984, what is the difference between the Number of enrolments of both sexes of Colombia and Number of enrolments of both sexes of Peru?
Make the answer very short. 5.24e+05. In the year 1984, what is the difference between the Number of enrolments of both sexes of Colombia and Number of enrolments of both sexes of United States?
Ensure brevity in your answer.  -1.58e+07. In the year 1984, what is the difference between the Number of enrolments of both sexes of Peru and Number of enrolments of both sexes of United States?
Your response must be concise. -1.64e+07. In the year 1985, what is the difference between the Number of enrolments of both sexes in China and Number of enrolments of both sexes in Colombia?
Your response must be concise. 1.32e+08. In the year 1985, what is the difference between the Number of enrolments of both sexes of China and Number of enrolments of both sexes of Peru?
Offer a terse response. 1.32e+08. In the year 1985, what is the difference between the Number of enrolments of both sexes in China and Number of enrolments of both sexes in United States?
Offer a terse response. 1.16e+08. In the year 1985, what is the difference between the Number of enrolments of both sexes of Colombia and Number of enrolments of both sexes of Peru?
Provide a short and direct response. 3.28e+05. In the year 1985, what is the difference between the Number of enrolments of both sexes in Colombia and Number of enrolments of both sexes in United States?
Offer a terse response. -1.58e+07. In the year 1985, what is the difference between the Number of enrolments of both sexes of Peru and Number of enrolments of both sexes of United States?
Keep it short and to the point. -1.62e+07. In the year 1986, what is the difference between the Number of enrolments of both sexes of China and Number of enrolments of both sexes of Colombia?
Give a very brief answer. 1.30e+08. In the year 1986, what is the difference between the Number of enrolments of both sexes of China and Number of enrolments of both sexes of Peru?
Your answer should be very brief. 1.30e+08. In the year 1986, what is the difference between the Number of enrolments of both sexes of China and Number of enrolments of both sexes of United States?
Keep it short and to the point. 1.13e+08. In the year 1986, what is the difference between the Number of enrolments of both sexes of Colombia and Number of enrolments of both sexes of Peru?
Offer a terse response. 4.02e+05. In the year 1986, what is the difference between the Number of enrolments of both sexes of Colombia and Number of enrolments of both sexes of United States?
Make the answer very short. -1.62e+07. In the year 1986, what is the difference between the Number of enrolments of both sexes in Peru and Number of enrolments of both sexes in United States?
Your answer should be very brief. -1.66e+07. In the year 1987, what is the difference between the Number of enrolments of both sexes in China and Number of enrolments of both sexes in Colombia?
Provide a succinct answer. 1.28e+08. In the year 1987, what is the difference between the Number of enrolments of both sexes of China and Number of enrolments of both sexes of Peru?
Provide a short and direct response. 1.28e+08. In the year 1987, what is the difference between the Number of enrolments of both sexes of China and Number of enrolments of both sexes of United States?
Your answer should be compact. 1.11e+08. In the year 1987, what is the difference between the Number of enrolments of both sexes of Colombia and Number of enrolments of both sexes of Peru?
Your answer should be compact. 4.52e+05. In the year 1987, what is the difference between the Number of enrolments of both sexes of Colombia and Number of enrolments of both sexes of United States?
Your response must be concise. -1.65e+07. In the year 1987, what is the difference between the Number of enrolments of both sexes in Peru and Number of enrolments of both sexes in United States?
Offer a very short reply. -1.69e+07. In the year 1990, what is the difference between the Number of enrolments of both sexes of China and Number of enrolments of both sexes of Colombia?
Keep it short and to the point. 1.19e+08. In the year 1990, what is the difference between the Number of enrolments of both sexes in China and Number of enrolments of both sexes in Peru?
Offer a very short reply. 1.20e+08. In the year 1990, what is the difference between the Number of enrolments of both sexes of China and Number of enrolments of both sexes of United States?
Keep it short and to the point. 1.01e+08. In the year 1990, what is the difference between the Number of enrolments of both sexes in Colombia and Number of enrolments of both sexes in Peru?
Keep it short and to the point. 3.91e+05. In the year 1990, what is the difference between the Number of enrolments of both sexes in Colombia and Number of enrolments of both sexes in United States?
Your answer should be compact. -1.80e+07. In the year 1990, what is the difference between the Number of enrolments of both sexes of Peru and Number of enrolments of both sexes of United States?
Give a very brief answer. -1.84e+07. What is the ratio of the Number of enrolments of both sexes in China in 1981 to that in 1982?
Provide a succinct answer. 1.02. What is the ratio of the Number of enrolments of both sexes of Colombia in 1981 to that in 1982?
Keep it short and to the point. 1.07. What is the ratio of the Number of enrolments of both sexes of Peru in 1981 to that in 1982?
Keep it short and to the point. 0.95. What is the ratio of the Number of enrolments of both sexes of China in 1981 to that in 1983?
Offer a terse response. 1.05. What is the ratio of the Number of enrolments of both sexes in Colombia in 1981 to that in 1983?
Your response must be concise. 1.06. What is the ratio of the Number of enrolments of both sexes in Peru in 1981 to that in 1983?
Your response must be concise. 0.95. What is the ratio of the Number of enrolments of both sexes in United States in 1981 to that in 1983?
Keep it short and to the point. 1.01. What is the ratio of the Number of enrolments of both sexes of China in 1981 to that in 1984?
Your answer should be compact. 1.08. What is the ratio of the Number of enrolments of both sexes of Colombia in 1981 to that in 1984?
Offer a very short reply. 1.05. What is the ratio of the Number of enrolments of both sexes in Peru in 1981 to that in 1984?
Make the answer very short. 0.93. What is the ratio of the Number of enrolments of both sexes in United States in 1981 to that in 1984?
Offer a terse response. 1.03. What is the ratio of the Number of enrolments of both sexes of China in 1981 to that in 1985?
Your response must be concise. 1.08. What is the ratio of the Number of enrolments of both sexes in Colombia in 1981 to that in 1985?
Your answer should be very brief. 1.04. What is the ratio of the Number of enrolments of both sexes in Peru in 1981 to that in 1985?
Your answer should be very brief. 0.88. What is the ratio of the Number of enrolments of both sexes in United States in 1981 to that in 1985?
Make the answer very short. 1.03. What is the ratio of the Number of enrolments of both sexes of China in 1981 to that in 1986?
Offer a very short reply. 1.09. What is the ratio of the Number of enrolments of both sexes of Colombia in 1981 to that in 1986?
Ensure brevity in your answer.  1.05. What is the ratio of the Number of enrolments of both sexes in Peru in 1981 to that in 1986?
Offer a very short reply. 0.9. What is the ratio of the Number of enrolments of both sexes of United States in 1981 to that in 1986?
Your response must be concise. 1.01. What is the ratio of the Number of enrolments of both sexes in China in 1981 to that in 1987?
Your answer should be compact. 1.11. What is the ratio of the Number of enrolments of both sexes of Peru in 1981 to that in 1987?
Your answer should be very brief. 0.89. What is the ratio of the Number of enrolments of both sexes in China in 1981 to that in 1990?
Keep it short and to the point. 1.18. What is the ratio of the Number of enrolments of both sexes of Peru in 1981 to that in 1990?
Give a very brief answer. 0.84. What is the ratio of the Number of enrolments of both sexes of United States in 1981 to that in 1990?
Provide a short and direct response. 0.92. What is the ratio of the Number of enrolments of both sexes of China in 1982 to that in 1983?
Provide a succinct answer. 1.03. What is the ratio of the Number of enrolments of both sexes of Colombia in 1982 to that in 1983?
Offer a very short reply. 0.99. What is the ratio of the Number of enrolments of both sexes in Peru in 1982 to that in 1983?
Your response must be concise. 1. What is the ratio of the Number of enrolments of both sexes in China in 1982 to that in 1984?
Offer a terse response. 1.06. What is the ratio of the Number of enrolments of both sexes in Colombia in 1982 to that in 1984?
Provide a short and direct response. 0.98. What is the ratio of the Number of enrolments of both sexes of Peru in 1982 to that in 1984?
Your response must be concise. 0.98. What is the ratio of the Number of enrolments of both sexes in United States in 1982 to that in 1984?
Give a very brief answer. 1.04. What is the ratio of the Number of enrolments of both sexes of China in 1982 to that in 1985?
Offer a very short reply. 1.06. What is the ratio of the Number of enrolments of both sexes of Colombia in 1982 to that in 1985?
Offer a terse response. 0.97. What is the ratio of the Number of enrolments of both sexes of Peru in 1982 to that in 1985?
Ensure brevity in your answer.  0.92. What is the ratio of the Number of enrolments of both sexes in United States in 1982 to that in 1985?
Offer a terse response. 1.04. What is the ratio of the Number of enrolments of both sexes of China in 1982 to that in 1986?
Your answer should be very brief. 1.07. What is the ratio of the Number of enrolments of both sexes in Colombia in 1982 to that in 1986?
Keep it short and to the point. 0.98. What is the ratio of the Number of enrolments of both sexes in Peru in 1982 to that in 1986?
Provide a short and direct response. 0.95. What is the ratio of the Number of enrolments of both sexes of United States in 1982 to that in 1986?
Ensure brevity in your answer.  1.02. What is the ratio of the Number of enrolments of both sexes of China in 1982 to that in 1987?
Your answer should be very brief. 1.09. What is the ratio of the Number of enrolments of both sexes in Colombia in 1982 to that in 1987?
Offer a very short reply. 0.96. What is the ratio of the Number of enrolments of both sexes in Peru in 1982 to that in 1987?
Ensure brevity in your answer.  0.93. What is the ratio of the Number of enrolments of both sexes of China in 1982 to that in 1990?
Keep it short and to the point. 1.16. What is the ratio of the Number of enrolments of both sexes in Colombia in 1982 to that in 1990?
Offer a terse response. 0.93. What is the ratio of the Number of enrolments of both sexes of Peru in 1982 to that in 1990?
Offer a terse response. 0.89. What is the ratio of the Number of enrolments of both sexes in United States in 1982 to that in 1990?
Give a very brief answer. 0.93. What is the ratio of the Number of enrolments of both sexes of Peru in 1983 to that in 1984?
Offer a very short reply. 0.98. What is the ratio of the Number of enrolments of both sexes of United States in 1983 to that in 1984?
Ensure brevity in your answer.  1.02. What is the ratio of the Number of enrolments of both sexes in China in 1983 to that in 1985?
Provide a short and direct response. 1.03. What is the ratio of the Number of enrolments of both sexes of Colombia in 1983 to that in 1985?
Give a very brief answer. 0.99. What is the ratio of the Number of enrolments of both sexes of Peru in 1983 to that in 1985?
Offer a very short reply. 0.92. What is the ratio of the Number of enrolments of both sexes in United States in 1983 to that in 1985?
Your answer should be very brief. 1.01. What is the ratio of the Number of enrolments of both sexes of China in 1983 to that in 1986?
Your response must be concise. 1.04. What is the ratio of the Number of enrolments of both sexes of Colombia in 1983 to that in 1986?
Offer a very short reply. 1. What is the ratio of the Number of enrolments of both sexes in Peru in 1983 to that in 1986?
Your answer should be very brief. 0.95. What is the ratio of the Number of enrolments of both sexes in China in 1983 to that in 1987?
Offer a very short reply. 1.06. What is the ratio of the Number of enrolments of both sexes in Colombia in 1983 to that in 1987?
Your response must be concise. 0.97. What is the ratio of the Number of enrolments of both sexes in Peru in 1983 to that in 1987?
Your answer should be compact. 0.94. What is the ratio of the Number of enrolments of both sexes in United States in 1983 to that in 1987?
Your answer should be very brief. 0.98. What is the ratio of the Number of enrolments of both sexes of China in 1983 to that in 1990?
Your answer should be compact. 1.13. What is the ratio of the Number of enrolments of both sexes of Colombia in 1983 to that in 1990?
Give a very brief answer. 0.94. What is the ratio of the Number of enrolments of both sexes of Peru in 1983 to that in 1990?
Give a very brief answer. 0.89. What is the ratio of the Number of enrolments of both sexes in United States in 1983 to that in 1990?
Ensure brevity in your answer.  0.91. What is the ratio of the Number of enrolments of both sexes of Colombia in 1984 to that in 1985?
Provide a short and direct response. 0.99. What is the ratio of the Number of enrolments of both sexes of Peru in 1984 to that in 1985?
Keep it short and to the point. 0.94. What is the ratio of the Number of enrolments of both sexes in China in 1984 to that in 1986?
Ensure brevity in your answer.  1.02. What is the ratio of the Number of enrolments of both sexes of Colombia in 1984 to that in 1986?
Provide a short and direct response. 1. What is the ratio of the Number of enrolments of both sexes in Peru in 1984 to that in 1986?
Provide a short and direct response. 0.97. What is the ratio of the Number of enrolments of both sexes in United States in 1984 to that in 1986?
Your answer should be compact. 0.98. What is the ratio of the Number of enrolments of both sexes of China in 1984 to that in 1987?
Provide a succinct answer. 1.03. What is the ratio of the Number of enrolments of both sexes of Colombia in 1984 to that in 1987?
Your answer should be compact. 0.97. What is the ratio of the Number of enrolments of both sexes of Peru in 1984 to that in 1987?
Give a very brief answer. 0.95. What is the ratio of the Number of enrolments of both sexes of United States in 1984 to that in 1987?
Ensure brevity in your answer.  0.96. What is the ratio of the Number of enrolments of both sexes in China in 1984 to that in 1990?
Keep it short and to the point. 1.1. What is the ratio of the Number of enrolments of both sexes in Colombia in 1984 to that in 1990?
Offer a very short reply. 0.94. What is the ratio of the Number of enrolments of both sexes of Peru in 1984 to that in 1990?
Make the answer very short. 0.9. What is the ratio of the Number of enrolments of both sexes of United States in 1984 to that in 1990?
Your answer should be compact. 0.89. What is the ratio of the Number of enrolments of both sexes in China in 1985 to that in 1986?
Make the answer very short. 1.01. What is the ratio of the Number of enrolments of both sexes of Colombia in 1985 to that in 1986?
Your answer should be compact. 1.01. What is the ratio of the Number of enrolments of both sexes of Peru in 1985 to that in 1986?
Make the answer very short. 1.03. What is the ratio of the Number of enrolments of both sexes in United States in 1985 to that in 1986?
Give a very brief answer. 0.98. What is the ratio of the Number of enrolments of both sexes in China in 1985 to that in 1987?
Your answer should be compact. 1.03. What is the ratio of the Number of enrolments of both sexes of Colombia in 1985 to that in 1987?
Your answer should be very brief. 0.98. What is the ratio of the Number of enrolments of both sexes in Peru in 1985 to that in 1987?
Provide a short and direct response. 1.01. What is the ratio of the Number of enrolments of both sexes of United States in 1985 to that in 1987?
Provide a succinct answer. 0.96. What is the ratio of the Number of enrolments of both sexes of China in 1985 to that in 1990?
Ensure brevity in your answer.  1.1. What is the ratio of the Number of enrolments of both sexes in Colombia in 1985 to that in 1990?
Keep it short and to the point. 0.95. What is the ratio of the Number of enrolments of both sexes of Peru in 1985 to that in 1990?
Provide a short and direct response. 0.96. What is the ratio of the Number of enrolments of both sexes in United States in 1985 to that in 1990?
Give a very brief answer. 0.89. What is the ratio of the Number of enrolments of both sexes in China in 1986 to that in 1987?
Keep it short and to the point. 1.01. What is the ratio of the Number of enrolments of both sexes in Colombia in 1986 to that in 1987?
Offer a very short reply. 0.97. What is the ratio of the Number of enrolments of both sexes in Peru in 1986 to that in 1987?
Give a very brief answer. 0.98. What is the ratio of the Number of enrolments of both sexes in United States in 1986 to that in 1987?
Make the answer very short. 0.98. What is the ratio of the Number of enrolments of both sexes of China in 1986 to that in 1990?
Provide a succinct answer. 1.08. What is the ratio of the Number of enrolments of both sexes of Colombia in 1986 to that in 1990?
Your response must be concise. 0.94. What is the ratio of the Number of enrolments of both sexes of Peru in 1986 to that in 1990?
Your answer should be compact. 0.93. What is the ratio of the Number of enrolments of both sexes of United States in 1986 to that in 1990?
Your answer should be very brief. 0.91. What is the ratio of the Number of enrolments of both sexes of China in 1987 to that in 1990?
Give a very brief answer. 1.07. What is the ratio of the Number of enrolments of both sexes in Colombia in 1987 to that in 1990?
Keep it short and to the point. 0.97. What is the ratio of the Number of enrolments of both sexes in Peru in 1987 to that in 1990?
Offer a terse response. 0.95. What is the ratio of the Number of enrolments of both sexes of United States in 1987 to that in 1990?
Your answer should be compact. 0.92. What is the difference between the highest and the second highest Number of enrolments of both sexes of China?
Ensure brevity in your answer.  2.94e+06. What is the difference between the highest and the second highest Number of enrolments of both sexes in Colombia?
Offer a very short reply. 2.89e+04. What is the difference between the highest and the second highest Number of enrolments of both sexes of Peru?
Offer a terse response. 1.44e+05. What is the difference between the highest and the second highest Number of enrolments of both sexes in United States?
Give a very brief answer. 1.67e+06. What is the difference between the highest and the lowest Number of enrolments of both sexes in China?
Provide a short and direct response. 2.25e+07. What is the difference between the highest and the lowest Number of enrolments of both sexes of Colombia?
Keep it short and to the point. 3.16e+05. What is the difference between the highest and the lowest Number of enrolments of both sexes of Peru?
Make the answer very short. 6.03e+05. What is the difference between the highest and the lowest Number of enrolments of both sexes in United States?
Keep it short and to the point. 2.44e+06. 